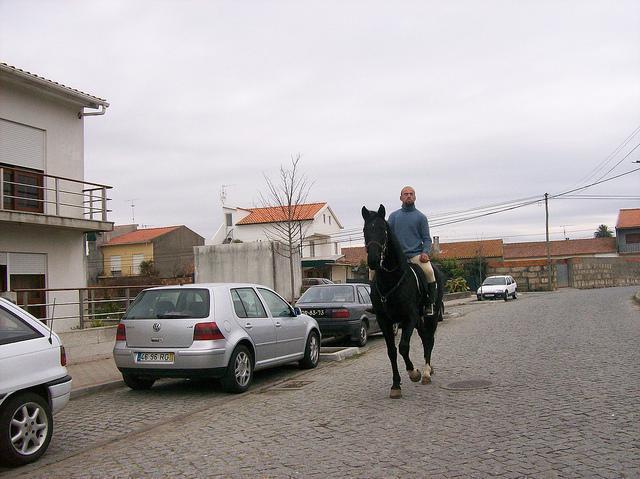What is he doing with the horse?
Choose the right answer and clarify with the format: 'Answer: answer
Rationale: rationale.'
Options: Riding it, stealing it, feeding it, mounting it. Answer: riding it.
Rationale: The man is mounted on the horse. 